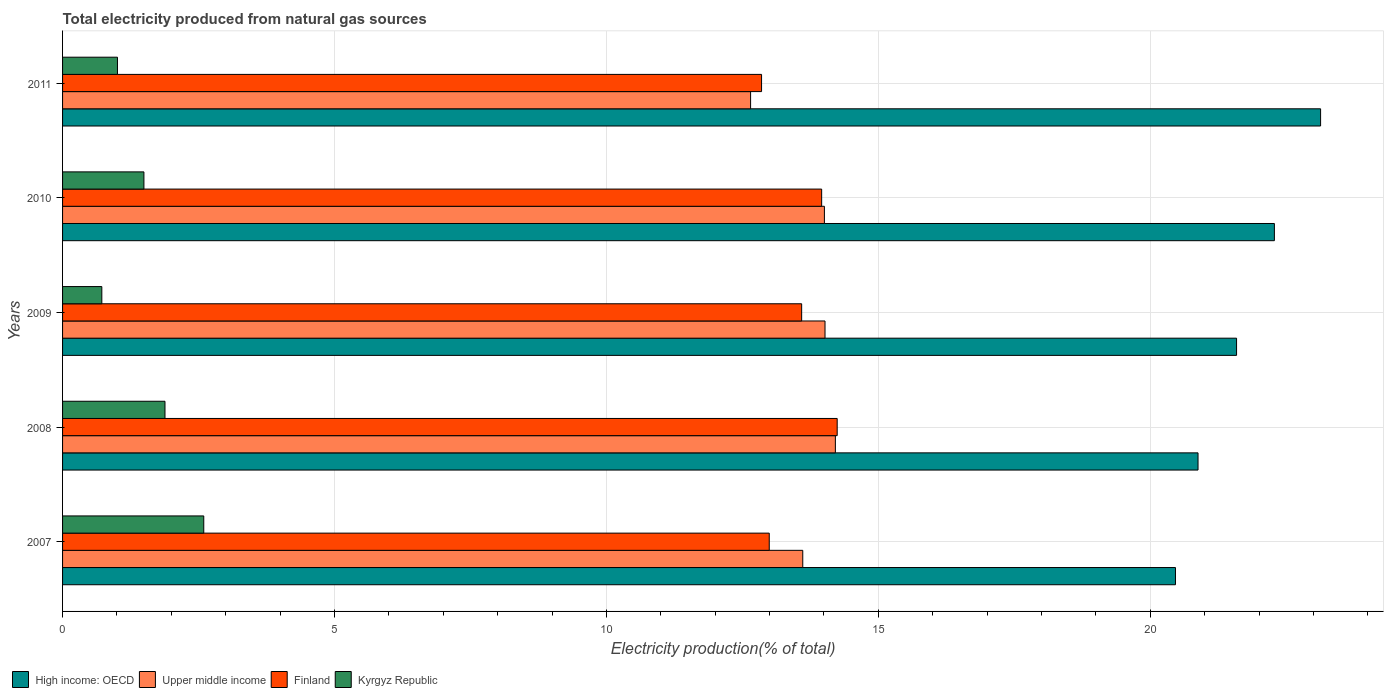Are the number of bars on each tick of the Y-axis equal?
Your response must be concise. Yes. In how many cases, is the number of bars for a given year not equal to the number of legend labels?
Your answer should be very brief. 0. What is the total electricity produced in Finland in 2007?
Provide a succinct answer. 12.99. Across all years, what is the maximum total electricity produced in Upper middle income?
Provide a short and direct response. 14.21. Across all years, what is the minimum total electricity produced in High income: OECD?
Offer a terse response. 20.46. In which year was the total electricity produced in Upper middle income minimum?
Your response must be concise. 2011. What is the total total electricity produced in High income: OECD in the graph?
Give a very brief answer. 108.34. What is the difference between the total electricity produced in Kyrgyz Republic in 2007 and that in 2008?
Provide a succinct answer. 0.71. What is the difference between the total electricity produced in Finland in 2008 and the total electricity produced in Kyrgyz Republic in 2007?
Your answer should be compact. 11.65. What is the average total electricity produced in Kyrgyz Republic per year?
Provide a succinct answer. 1.54. In the year 2010, what is the difference between the total electricity produced in Upper middle income and total electricity produced in Kyrgyz Republic?
Your answer should be compact. 12.51. In how many years, is the total electricity produced in Kyrgyz Republic greater than 19 %?
Offer a terse response. 0. What is the ratio of the total electricity produced in Upper middle income in 2007 to that in 2009?
Offer a very short reply. 0.97. Is the total electricity produced in Kyrgyz Republic in 2007 less than that in 2009?
Offer a terse response. No. Is the difference between the total electricity produced in Upper middle income in 2007 and 2009 greater than the difference between the total electricity produced in Kyrgyz Republic in 2007 and 2009?
Your answer should be compact. No. What is the difference between the highest and the second highest total electricity produced in High income: OECD?
Offer a terse response. 0.85. What is the difference between the highest and the lowest total electricity produced in Kyrgyz Republic?
Provide a succinct answer. 1.87. In how many years, is the total electricity produced in Finland greater than the average total electricity produced in Finland taken over all years?
Offer a terse response. 3. Is the sum of the total electricity produced in Finland in 2007 and 2010 greater than the maximum total electricity produced in High income: OECD across all years?
Your answer should be compact. Yes. What does the 1st bar from the top in 2010 represents?
Offer a very short reply. Kyrgyz Republic. What does the 2nd bar from the bottom in 2011 represents?
Provide a succinct answer. Upper middle income. Is it the case that in every year, the sum of the total electricity produced in Upper middle income and total electricity produced in Finland is greater than the total electricity produced in High income: OECD?
Offer a terse response. Yes. How many bars are there?
Give a very brief answer. 20. How many years are there in the graph?
Give a very brief answer. 5. Are the values on the major ticks of X-axis written in scientific E-notation?
Your answer should be very brief. No. Does the graph contain any zero values?
Give a very brief answer. No. What is the title of the graph?
Give a very brief answer. Total electricity produced from natural gas sources. What is the label or title of the X-axis?
Make the answer very short. Electricity production(% of total). What is the label or title of the Y-axis?
Give a very brief answer. Years. What is the Electricity production(% of total) of High income: OECD in 2007?
Your answer should be compact. 20.46. What is the Electricity production(% of total) in Upper middle income in 2007?
Keep it short and to the point. 13.61. What is the Electricity production(% of total) in Finland in 2007?
Your answer should be very brief. 12.99. What is the Electricity production(% of total) in Kyrgyz Republic in 2007?
Offer a terse response. 2.6. What is the Electricity production(% of total) in High income: OECD in 2008?
Your response must be concise. 20.88. What is the Electricity production(% of total) of Upper middle income in 2008?
Make the answer very short. 14.21. What is the Electricity production(% of total) in Finland in 2008?
Your response must be concise. 14.24. What is the Electricity production(% of total) of Kyrgyz Republic in 2008?
Provide a short and direct response. 1.88. What is the Electricity production(% of total) of High income: OECD in 2009?
Your response must be concise. 21.59. What is the Electricity production(% of total) in Upper middle income in 2009?
Offer a very short reply. 14.02. What is the Electricity production(% of total) in Finland in 2009?
Keep it short and to the point. 13.59. What is the Electricity production(% of total) in Kyrgyz Republic in 2009?
Your answer should be very brief. 0.72. What is the Electricity production(% of total) in High income: OECD in 2010?
Provide a short and direct response. 22.28. What is the Electricity production(% of total) of Upper middle income in 2010?
Ensure brevity in your answer.  14.01. What is the Electricity production(% of total) of Finland in 2010?
Offer a terse response. 13.96. What is the Electricity production(% of total) of Kyrgyz Republic in 2010?
Offer a very short reply. 1.5. What is the Electricity production(% of total) of High income: OECD in 2011?
Ensure brevity in your answer.  23.13. What is the Electricity production(% of total) of Upper middle income in 2011?
Provide a short and direct response. 12.65. What is the Electricity production(% of total) of Finland in 2011?
Provide a succinct answer. 12.85. What is the Electricity production(% of total) of Kyrgyz Republic in 2011?
Make the answer very short. 1.01. Across all years, what is the maximum Electricity production(% of total) in High income: OECD?
Your answer should be compact. 23.13. Across all years, what is the maximum Electricity production(% of total) of Upper middle income?
Give a very brief answer. 14.21. Across all years, what is the maximum Electricity production(% of total) of Finland?
Make the answer very short. 14.24. Across all years, what is the maximum Electricity production(% of total) in Kyrgyz Republic?
Offer a very short reply. 2.6. Across all years, what is the minimum Electricity production(% of total) of High income: OECD?
Make the answer very short. 20.46. Across all years, what is the minimum Electricity production(% of total) of Upper middle income?
Make the answer very short. 12.65. Across all years, what is the minimum Electricity production(% of total) in Finland?
Give a very brief answer. 12.85. Across all years, what is the minimum Electricity production(% of total) of Kyrgyz Republic?
Keep it short and to the point. 0.72. What is the total Electricity production(% of total) of High income: OECD in the graph?
Offer a terse response. 108.34. What is the total Electricity production(% of total) of Upper middle income in the graph?
Keep it short and to the point. 68.5. What is the total Electricity production(% of total) in Finland in the graph?
Provide a short and direct response. 67.64. What is the total Electricity production(% of total) in Kyrgyz Republic in the graph?
Provide a succinct answer. 7.71. What is the difference between the Electricity production(% of total) in High income: OECD in 2007 and that in 2008?
Offer a very short reply. -0.41. What is the difference between the Electricity production(% of total) of Upper middle income in 2007 and that in 2008?
Keep it short and to the point. -0.6. What is the difference between the Electricity production(% of total) in Finland in 2007 and that in 2008?
Keep it short and to the point. -1.25. What is the difference between the Electricity production(% of total) of Kyrgyz Republic in 2007 and that in 2008?
Offer a terse response. 0.71. What is the difference between the Electricity production(% of total) in High income: OECD in 2007 and that in 2009?
Offer a very short reply. -1.12. What is the difference between the Electricity production(% of total) in Upper middle income in 2007 and that in 2009?
Offer a very short reply. -0.41. What is the difference between the Electricity production(% of total) in Finland in 2007 and that in 2009?
Give a very brief answer. -0.6. What is the difference between the Electricity production(% of total) of Kyrgyz Republic in 2007 and that in 2009?
Your answer should be compact. 1.87. What is the difference between the Electricity production(% of total) in High income: OECD in 2007 and that in 2010?
Your answer should be compact. -1.82. What is the difference between the Electricity production(% of total) of Upper middle income in 2007 and that in 2010?
Give a very brief answer. -0.4. What is the difference between the Electricity production(% of total) of Finland in 2007 and that in 2010?
Your answer should be very brief. -0.96. What is the difference between the Electricity production(% of total) of Kyrgyz Republic in 2007 and that in 2010?
Make the answer very short. 1.1. What is the difference between the Electricity production(% of total) of High income: OECD in 2007 and that in 2011?
Offer a very short reply. -2.67. What is the difference between the Electricity production(% of total) in Upper middle income in 2007 and that in 2011?
Give a very brief answer. 0.96. What is the difference between the Electricity production(% of total) of Finland in 2007 and that in 2011?
Your response must be concise. 0.14. What is the difference between the Electricity production(% of total) in Kyrgyz Republic in 2007 and that in 2011?
Provide a short and direct response. 1.59. What is the difference between the Electricity production(% of total) of High income: OECD in 2008 and that in 2009?
Offer a terse response. -0.71. What is the difference between the Electricity production(% of total) of Upper middle income in 2008 and that in 2009?
Keep it short and to the point. 0.19. What is the difference between the Electricity production(% of total) in Finland in 2008 and that in 2009?
Make the answer very short. 0.65. What is the difference between the Electricity production(% of total) in Kyrgyz Republic in 2008 and that in 2009?
Give a very brief answer. 1.16. What is the difference between the Electricity production(% of total) of High income: OECD in 2008 and that in 2010?
Your answer should be very brief. -1.4. What is the difference between the Electricity production(% of total) of Upper middle income in 2008 and that in 2010?
Your answer should be very brief. 0.2. What is the difference between the Electricity production(% of total) in Finland in 2008 and that in 2010?
Your answer should be compact. 0.29. What is the difference between the Electricity production(% of total) in Kyrgyz Republic in 2008 and that in 2010?
Offer a very short reply. 0.39. What is the difference between the Electricity production(% of total) of High income: OECD in 2008 and that in 2011?
Give a very brief answer. -2.25. What is the difference between the Electricity production(% of total) of Upper middle income in 2008 and that in 2011?
Ensure brevity in your answer.  1.56. What is the difference between the Electricity production(% of total) in Finland in 2008 and that in 2011?
Give a very brief answer. 1.39. What is the difference between the Electricity production(% of total) of Kyrgyz Republic in 2008 and that in 2011?
Provide a succinct answer. 0.87. What is the difference between the Electricity production(% of total) in High income: OECD in 2009 and that in 2010?
Keep it short and to the point. -0.7. What is the difference between the Electricity production(% of total) of Upper middle income in 2009 and that in 2010?
Provide a short and direct response. 0.01. What is the difference between the Electricity production(% of total) in Finland in 2009 and that in 2010?
Your answer should be compact. -0.37. What is the difference between the Electricity production(% of total) in Kyrgyz Republic in 2009 and that in 2010?
Provide a succinct answer. -0.77. What is the difference between the Electricity production(% of total) in High income: OECD in 2009 and that in 2011?
Offer a terse response. -1.54. What is the difference between the Electricity production(% of total) in Upper middle income in 2009 and that in 2011?
Offer a very short reply. 1.37. What is the difference between the Electricity production(% of total) of Finland in 2009 and that in 2011?
Offer a very short reply. 0.74. What is the difference between the Electricity production(% of total) of Kyrgyz Republic in 2009 and that in 2011?
Provide a short and direct response. -0.29. What is the difference between the Electricity production(% of total) in High income: OECD in 2010 and that in 2011?
Provide a succinct answer. -0.85. What is the difference between the Electricity production(% of total) of Upper middle income in 2010 and that in 2011?
Make the answer very short. 1.36. What is the difference between the Electricity production(% of total) in Finland in 2010 and that in 2011?
Your answer should be compact. 1.1. What is the difference between the Electricity production(% of total) in Kyrgyz Republic in 2010 and that in 2011?
Ensure brevity in your answer.  0.49. What is the difference between the Electricity production(% of total) of High income: OECD in 2007 and the Electricity production(% of total) of Upper middle income in 2008?
Your answer should be very brief. 6.25. What is the difference between the Electricity production(% of total) in High income: OECD in 2007 and the Electricity production(% of total) in Finland in 2008?
Provide a succinct answer. 6.22. What is the difference between the Electricity production(% of total) of High income: OECD in 2007 and the Electricity production(% of total) of Kyrgyz Republic in 2008?
Your response must be concise. 18.58. What is the difference between the Electricity production(% of total) in Upper middle income in 2007 and the Electricity production(% of total) in Finland in 2008?
Offer a very short reply. -0.63. What is the difference between the Electricity production(% of total) of Upper middle income in 2007 and the Electricity production(% of total) of Kyrgyz Republic in 2008?
Your response must be concise. 11.73. What is the difference between the Electricity production(% of total) of Finland in 2007 and the Electricity production(% of total) of Kyrgyz Republic in 2008?
Keep it short and to the point. 11.11. What is the difference between the Electricity production(% of total) in High income: OECD in 2007 and the Electricity production(% of total) in Upper middle income in 2009?
Your answer should be very brief. 6.44. What is the difference between the Electricity production(% of total) in High income: OECD in 2007 and the Electricity production(% of total) in Finland in 2009?
Provide a short and direct response. 6.87. What is the difference between the Electricity production(% of total) in High income: OECD in 2007 and the Electricity production(% of total) in Kyrgyz Republic in 2009?
Offer a terse response. 19.74. What is the difference between the Electricity production(% of total) of Upper middle income in 2007 and the Electricity production(% of total) of Finland in 2009?
Keep it short and to the point. 0.02. What is the difference between the Electricity production(% of total) in Upper middle income in 2007 and the Electricity production(% of total) in Kyrgyz Republic in 2009?
Offer a very short reply. 12.89. What is the difference between the Electricity production(% of total) in Finland in 2007 and the Electricity production(% of total) in Kyrgyz Republic in 2009?
Offer a terse response. 12.27. What is the difference between the Electricity production(% of total) of High income: OECD in 2007 and the Electricity production(% of total) of Upper middle income in 2010?
Ensure brevity in your answer.  6.46. What is the difference between the Electricity production(% of total) in High income: OECD in 2007 and the Electricity production(% of total) in Finland in 2010?
Provide a succinct answer. 6.51. What is the difference between the Electricity production(% of total) in High income: OECD in 2007 and the Electricity production(% of total) in Kyrgyz Republic in 2010?
Provide a succinct answer. 18.97. What is the difference between the Electricity production(% of total) in Upper middle income in 2007 and the Electricity production(% of total) in Finland in 2010?
Offer a very short reply. -0.35. What is the difference between the Electricity production(% of total) of Upper middle income in 2007 and the Electricity production(% of total) of Kyrgyz Republic in 2010?
Offer a very short reply. 12.11. What is the difference between the Electricity production(% of total) of Finland in 2007 and the Electricity production(% of total) of Kyrgyz Republic in 2010?
Keep it short and to the point. 11.5. What is the difference between the Electricity production(% of total) of High income: OECD in 2007 and the Electricity production(% of total) of Upper middle income in 2011?
Your answer should be very brief. 7.81. What is the difference between the Electricity production(% of total) in High income: OECD in 2007 and the Electricity production(% of total) in Finland in 2011?
Provide a succinct answer. 7.61. What is the difference between the Electricity production(% of total) in High income: OECD in 2007 and the Electricity production(% of total) in Kyrgyz Republic in 2011?
Your answer should be compact. 19.45. What is the difference between the Electricity production(% of total) in Upper middle income in 2007 and the Electricity production(% of total) in Finland in 2011?
Offer a very short reply. 0.76. What is the difference between the Electricity production(% of total) of Upper middle income in 2007 and the Electricity production(% of total) of Kyrgyz Republic in 2011?
Your response must be concise. 12.6. What is the difference between the Electricity production(% of total) of Finland in 2007 and the Electricity production(% of total) of Kyrgyz Republic in 2011?
Offer a very short reply. 11.98. What is the difference between the Electricity production(% of total) of High income: OECD in 2008 and the Electricity production(% of total) of Upper middle income in 2009?
Ensure brevity in your answer.  6.86. What is the difference between the Electricity production(% of total) of High income: OECD in 2008 and the Electricity production(% of total) of Finland in 2009?
Provide a short and direct response. 7.29. What is the difference between the Electricity production(% of total) of High income: OECD in 2008 and the Electricity production(% of total) of Kyrgyz Republic in 2009?
Provide a short and direct response. 20.16. What is the difference between the Electricity production(% of total) of Upper middle income in 2008 and the Electricity production(% of total) of Finland in 2009?
Offer a very short reply. 0.62. What is the difference between the Electricity production(% of total) in Upper middle income in 2008 and the Electricity production(% of total) in Kyrgyz Republic in 2009?
Your answer should be very brief. 13.49. What is the difference between the Electricity production(% of total) in Finland in 2008 and the Electricity production(% of total) in Kyrgyz Republic in 2009?
Give a very brief answer. 13.52. What is the difference between the Electricity production(% of total) in High income: OECD in 2008 and the Electricity production(% of total) in Upper middle income in 2010?
Give a very brief answer. 6.87. What is the difference between the Electricity production(% of total) in High income: OECD in 2008 and the Electricity production(% of total) in Finland in 2010?
Your answer should be very brief. 6.92. What is the difference between the Electricity production(% of total) in High income: OECD in 2008 and the Electricity production(% of total) in Kyrgyz Republic in 2010?
Ensure brevity in your answer.  19.38. What is the difference between the Electricity production(% of total) in Upper middle income in 2008 and the Electricity production(% of total) in Finland in 2010?
Your answer should be compact. 0.25. What is the difference between the Electricity production(% of total) in Upper middle income in 2008 and the Electricity production(% of total) in Kyrgyz Republic in 2010?
Provide a short and direct response. 12.71. What is the difference between the Electricity production(% of total) of Finland in 2008 and the Electricity production(% of total) of Kyrgyz Republic in 2010?
Make the answer very short. 12.75. What is the difference between the Electricity production(% of total) in High income: OECD in 2008 and the Electricity production(% of total) in Upper middle income in 2011?
Ensure brevity in your answer.  8.23. What is the difference between the Electricity production(% of total) of High income: OECD in 2008 and the Electricity production(% of total) of Finland in 2011?
Offer a terse response. 8.03. What is the difference between the Electricity production(% of total) in High income: OECD in 2008 and the Electricity production(% of total) in Kyrgyz Republic in 2011?
Keep it short and to the point. 19.87. What is the difference between the Electricity production(% of total) of Upper middle income in 2008 and the Electricity production(% of total) of Finland in 2011?
Give a very brief answer. 1.36. What is the difference between the Electricity production(% of total) of Upper middle income in 2008 and the Electricity production(% of total) of Kyrgyz Republic in 2011?
Make the answer very short. 13.2. What is the difference between the Electricity production(% of total) of Finland in 2008 and the Electricity production(% of total) of Kyrgyz Republic in 2011?
Provide a succinct answer. 13.23. What is the difference between the Electricity production(% of total) in High income: OECD in 2009 and the Electricity production(% of total) in Upper middle income in 2010?
Ensure brevity in your answer.  7.58. What is the difference between the Electricity production(% of total) of High income: OECD in 2009 and the Electricity production(% of total) of Finland in 2010?
Make the answer very short. 7.63. What is the difference between the Electricity production(% of total) in High income: OECD in 2009 and the Electricity production(% of total) in Kyrgyz Republic in 2010?
Make the answer very short. 20.09. What is the difference between the Electricity production(% of total) in Upper middle income in 2009 and the Electricity production(% of total) in Finland in 2010?
Your answer should be compact. 0.06. What is the difference between the Electricity production(% of total) in Upper middle income in 2009 and the Electricity production(% of total) in Kyrgyz Republic in 2010?
Keep it short and to the point. 12.52. What is the difference between the Electricity production(% of total) in Finland in 2009 and the Electricity production(% of total) in Kyrgyz Republic in 2010?
Make the answer very short. 12.09. What is the difference between the Electricity production(% of total) in High income: OECD in 2009 and the Electricity production(% of total) in Upper middle income in 2011?
Offer a very short reply. 8.94. What is the difference between the Electricity production(% of total) in High income: OECD in 2009 and the Electricity production(% of total) in Finland in 2011?
Keep it short and to the point. 8.73. What is the difference between the Electricity production(% of total) in High income: OECD in 2009 and the Electricity production(% of total) in Kyrgyz Republic in 2011?
Ensure brevity in your answer.  20.58. What is the difference between the Electricity production(% of total) in Upper middle income in 2009 and the Electricity production(% of total) in Finland in 2011?
Offer a very short reply. 1.17. What is the difference between the Electricity production(% of total) in Upper middle income in 2009 and the Electricity production(% of total) in Kyrgyz Republic in 2011?
Provide a short and direct response. 13.01. What is the difference between the Electricity production(% of total) in Finland in 2009 and the Electricity production(% of total) in Kyrgyz Republic in 2011?
Your response must be concise. 12.58. What is the difference between the Electricity production(% of total) in High income: OECD in 2010 and the Electricity production(% of total) in Upper middle income in 2011?
Your answer should be compact. 9.63. What is the difference between the Electricity production(% of total) of High income: OECD in 2010 and the Electricity production(% of total) of Finland in 2011?
Ensure brevity in your answer.  9.43. What is the difference between the Electricity production(% of total) in High income: OECD in 2010 and the Electricity production(% of total) in Kyrgyz Republic in 2011?
Give a very brief answer. 21.27. What is the difference between the Electricity production(% of total) of Upper middle income in 2010 and the Electricity production(% of total) of Finland in 2011?
Your answer should be compact. 1.16. What is the difference between the Electricity production(% of total) of Upper middle income in 2010 and the Electricity production(% of total) of Kyrgyz Republic in 2011?
Offer a terse response. 13. What is the difference between the Electricity production(% of total) of Finland in 2010 and the Electricity production(% of total) of Kyrgyz Republic in 2011?
Keep it short and to the point. 12.95. What is the average Electricity production(% of total) of High income: OECD per year?
Provide a succinct answer. 21.67. What is the average Electricity production(% of total) in Upper middle income per year?
Offer a very short reply. 13.7. What is the average Electricity production(% of total) in Finland per year?
Make the answer very short. 13.53. What is the average Electricity production(% of total) in Kyrgyz Republic per year?
Your answer should be compact. 1.54. In the year 2007, what is the difference between the Electricity production(% of total) of High income: OECD and Electricity production(% of total) of Upper middle income?
Offer a very short reply. 6.85. In the year 2007, what is the difference between the Electricity production(% of total) of High income: OECD and Electricity production(% of total) of Finland?
Your answer should be very brief. 7.47. In the year 2007, what is the difference between the Electricity production(% of total) in High income: OECD and Electricity production(% of total) in Kyrgyz Republic?
Offer a very short reply. 17.87. In the year 2007, what is the difference between the Electricity production(% of total) in Upper middle income and Electricity production(% of total) in Finland?
Offer a terse response. 0.62. In the year 2007, what is the difference between the Electricity production(% of total) in Upper middle income and Electricity production(% of total) in Kyrgyz Republic?
Give a very brief answer. 11.01. In the year 2007, what is the difference between the Electricity production(% of total) in Finland and Electricity production(% of total) in Kyrgyz Republic?
Ensure brevity in your answer.  10.4. In the year 2008, what is the difference between the Electricity production(% of total) in High income: OECD and Electricity production(% of total) in Upper middle income?
Provide a short and direct response. 6.67. In the year 2008, what is the difference between the Electricity production(% of total) of High income: OECD and Electricity production(% of total) of Finland?
Provide a succinct answer. 6.63. In the year 2008, what is the difference between the Electricity production(% of total) of High income: OECD and Electricity production(% of total) of Kyrgyz Republic?
Ensure brevity in your answer.  18.99. In the year 2008, what is the difference between the Electricity production(% of total) in Upper middle income and Electricity production(% of total) in Finland?
Your response must be concise. -0.03. In the year 2008, what is the difference between the Electricity production(% of total) in Upper middle income and Electricity production(% of total) in Kyrgyz Republic?
Your answer should be very brief. 12.33. In the year 2008, what is the difference between the Electricity production(% of total) in Finland and Electricity production(% of total) in Kyrgyz Republic?
Offer a terse response. 12.36. In the year 2009, what is the difference between the Electricity production(% of total) of High income: OECD and Electricity production(% of total) of Upper middle income?
Your answer should be compact. 7.57. In the year 2009, what is the difference between the Electricity production(% of total) in High income: OECD and Electricity production(% of total) in Finland?
Your response must be concise. 8. In the year 2009, what is the difference between the Electricity production(% of total) in High income: OECD and Electricity production(% of total) in Kyrgyz Republic?
Your response must be concise. 20.86. In the year 2009, what is the difference between the Electricity production(% of total) in Upper middle income and Electricity production(% of total) in Finland?
Provide a short and direct response. 0.43. In the year 2009, what is the difference between the Electricity production(% of total) in Upper middle income and Electricity production(% of total) in Kyrgyz Republic?
Offer a terse response. 13.3. In the year 2009, what is the difference between the Electricity production(% of total) in Finland and Electricity production(% of total) in Kyrgyz Republic?
Make the answer very short. 12.87. In the year 2010, what is the difference between the Electricity production(% of total) of High income: OECD and Electricity production(% of total) of Upper middle income?
Ensure brevity in your answer.  8.27. In the year 2010, what is the difference between the Electricity production(% of total) in High income: OECD and Electricity production(% of total) in Finland?
Offer a very short reply. 8.32. In the year 2010, what is the difference between the Electricity production(% of total) in High income: OECD and Electricity production(% of total) in Kyrgyz Republic?
Keep it short and to the point. 20.79. In the year 2010, what is the difference between the Electricity production(% of total) of Upper middle income and Electricity production(% of total) of Finland?
Offer a very short reply. 0.05. In the year 2010, what is the difference between the Electricity production(% of total) in Upper middle income and Electricity production(% of total) in Kyrgyz Republic?
Your response must be concise. 12.51. In the year 2010, what is the difference between the Electricity production(% of total) in Finland and Electricity production(% of total) in Kyrgyz Republic?
Your answer should be very brief. 12.46. In the year 2011, what is the difference between the Electricity production(% of total) of High income: OECD and Electricity production(% of total) of Upper middle income?
Your response must be concise. 10.48. In the year 2011, what is the difference between the Electricity production(% of total) of High income: OECD and Electricity production(% of total) of Finland?
Ensure brevity in your answer.  10.28. In the year 2011, what is the difference between the Electricity production(% of total) in High income: OECD and Electricity production(% of total) in Kyrgyz Republic?
Offer a very short reply. 22.12. In the year 2011, what is the difference between the Electricity production(% of total) of Upper middle income and Electricity production(% of total) of Finland?
Provide a short and direct response. -0.2. In the year 2011, what is the difference between the Electricity production(% of total) in Upper middle income and Electricity production(% of total) in Kyrgyz Republic?
Your answer should be compact. 11.64. In the year 2011, what is the difference between the Electricity production(% of total) of Finland and Electricity production(% of total) of Kyrgyz Republic?
Provide a short and direct response. 11.84. What is the ratio of the Electricity production(% of total) in High income: OECD in 2007 to that in 2008?
Keep it short and to the point. 0.98. What is the ratio of the Electricity production(% of total) of Upper middle income in 2007 to that in 2008?
Your answer should be compact. 0.96. What is the ratio of the Electricity production(% of total) of Finland in 2007 to that in 2008?
Offer a very short reply. 0.91. What is the ratio of the Electricity production(% of total) in Kyrgyz Republic in 2007 to that in 2008?
Provide a short and direct response. 1.38. What is the ratio of the Electricity production(% of total) in High income: OECD in 2007 to that in 2009?
Give a very brief answer. 0.95. What is the ratio of the Electricity production(% of total) of Upper middle income in 2007 to that in 2009?
Your answer should be very brief. 0.97. What is the ratio of the Electricity production(% of total) of Finland in 2007 to that in 2009?
Provide a succinct answer. 0.96. What is the ratio of the Electricity production(% of total) in Kyrgyz Republic in 2007 to that in 2009?
Provide a short and direct response. 3.6. What is the ratio of the Electricity production(% of total) of High income: OECD in 2007 to that in 2010?
Keep it short and to the point. 0.92. What is the ratio of the Electricity production(% of total) of Upper middle income in 2007 to that in 2010?
Give a very brief answer. 0.97. What is the ratio of the Electricity production(% of total) in Kyrgyz Republic in 2007 to that in 2010?
Your answer should be very brief. 1.74. What is the ratio of the Electricity production(% of total) of High income: OECD in 2007 to that in 2011?
Offer a very short reply. 0.88. What is the ratio of the Electricity production(% of total) of Upper middle income in 2007 to that in 2011?
Make the answer very short. 1.08. What is the ratio of the Electricity production(% of total) in Finland in 2007 to that in 2011?
Keep it short and to the point. 1.01. What is the ratio of the Electricity production(% of total) of Kyrgyz Republic in 2007 to that in 2011?
Provide a succinct answer. 2.57. What is the ratio of the Electricity production(% of total) of High income: OECD in 2008 to that in 2009?
Keep it short and to the point. 0.97. What is the ratio of the Electricity production(% of total) in Upper middle income in 2008 to that in 2009?
Offer a terse response. 1.01. What is the ratio of the Electricity production(% of total) of Finland in 2008 to that in 2009?
Make the answer very short. 1.05. What is the ratio of the Electricity production(% of total) of Kyrgyz Republic in 2008 to that in 2009?
Offer a very short reply. 2.61. What is the ratio of the Electricity production(% of total) of High income: OECD in 2008 to that in 2010?
Your answer should be very brief. 0.94. What is the ratio of the Electricity production(% of total) in Upper middle income in 2008 to that in 2010?
Your response must be concise. 1.01. What is the ratio of the Electricity production(% of total) in Finland in 2008 to that in 2010?
Give a very brief answer. 1.02. What is the ratio of the Electricity production(% of total) in Kyrgyz Republic in 2008 to that in 2010?
Provide a short and direct response. 1.26. What is the ratio of the Electricity production(% of total) in High income: OECD in 2008 to that in 2011?
Your answer should be compact. 0.9. What is the ratio of the Electricity production(% of total) of Upper middle income in 2008 to that in 2011?
Provide a short and direct response. 1.12. What is the ratio of the Electricity production(% of total) in Finland in 2008 to that in 2011?
Provide a succinct answer. 1.11. What is the ratio of the Electricity production(% of total) in Kyrgyz Republic in 2008 to that in 2011?
Give a very brief answer. 1.87. What is the ratio of the Electricity production(% of total) in High income: OECD in 2009 to that in 2010?
Ensure brevity in your answer.  0.97. What is the ratio of the Electricity production(% of total) of Upper middle income in 2009 to that in 2010?
Offer a very short reply. 1. What is the ratio of the Electricity production(% of total) in Finland in 2009 to that in 2010?
Provide a succinct answer. 0.97. What is the ratio of the Electricity production(% of total) of Kyrgyz Republic in 2009 to that in 2010?
Keep it short and to the point. 0.48. What is the ratio of the Electricity production(% of total) of High income: OECD in 2009 to that in 2011?
Give a very brief answer. 0.93. What is the ratio of the Electricity production(% of total) of Upper middle income in 2009 to that in 2011?
Provide a succinct answer. 1.11. What is the ratio of the Electricity production(% of total) of Finland in 2009 to that in 2011?
Provide a succinct answer. 1.06. What is the ratio of the Electricity production(% of total) of Kyrgyz Republic in 2009 to that in 2011?
Your answer should be compact. 0.72. What is the ratio of the Electricity production(% of total) in High income: OECD in 2010 to that in 2011?
Provide a short and direct response. 0.96. What is the ratio of the Electricity production(% of total) of Upper middle income in 2010 to that in 2011?
Keep it short and to the point. 1.11. What is the ratio of the Electricity production(% of total) of Finland in 2010 to that in 2011?
Your answer should be very brief. 1.09. What is the ratio of the Electricity production(% of total) of Kyrgyz Republic in 2010 to that in 2011?
Your answer should be very brief. 1.48. What is the difference between the highest and the second highest Electricity production(% of total) in High income: OECD?
Make the answer very short. 0.85. What is the difference between the highest and the second highest Electricity production(% of total) of Upper middle income?
Offer a terse response. 0.19. What is the difference between the highest and the second highest Electricity production(% of total) of Finland?
Offer a terse response. 0.29. What is the difference between the highest and the second highest Electricity production(% of total) of Kyrgyz Republic?
Ensure brevity in your answer.  0.71. What is the difference between the highest and the lowest Electricity production(% of total) in High income: OECD?
Your answer should be very brief. 2.67. What is the difference between the highest and the lowest Electricity production(% of total) of Upper middle income?
Give a very brief answer. 1.56. What is the difference between the highest and the lowest Electricity production(% of total) of Finland?
Provide a succinct answer. 1.39. What is the difference between the highest and the lowest Electricity production(% of total) in Kyrgyz Republic?
Your answer should be very brief. 1.87. 